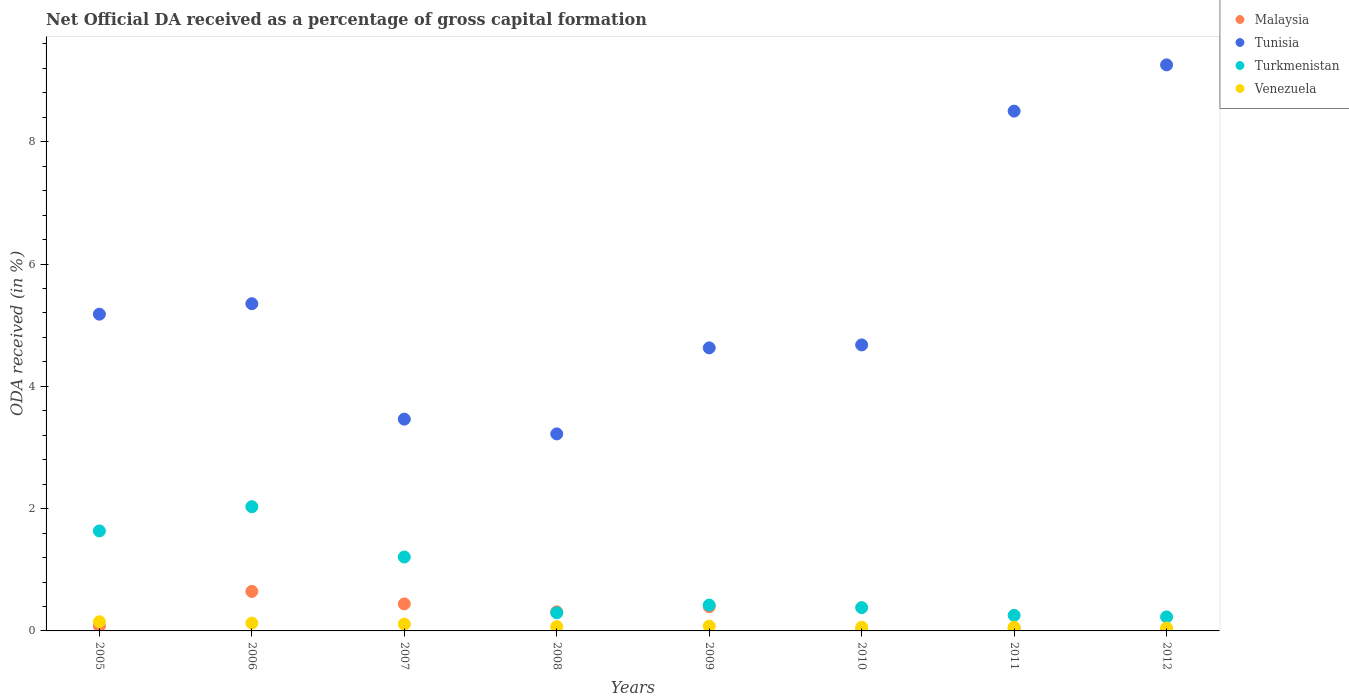How many different coloured dotlines are there?
Offer a terse response. 4. What is the net ODA received in Malaysia in 2009?
Offer a terse response. 0.4. Across all years, what is the maximum net ODA received in Venezuela?
Offer a terse response. 0.15. Across all years, what is the minimum net ODA received in Turkmenistan?
Your answer should be compact. 0.23. In which year was the net ODA received in Tunisia maximum?
Provide a succinct answer. 2012. What is the total net ODA received in Tunisia in the graph?
Your answer should be compact. 44.28. What is the difference between the net ODA received in Malaysia in 2007 and that in 2008?
Make the answer very short. 0.13. What is the difference between the net ODA received in Tunisia in 2011 and the net ODA received in Venezuela in 2012?
Offer a very short reply. 8.45. What is the average net ODA received in Venezuela per year?
Keep it short and to the point. 0.09. In the year 2010, what is the difference between the net ODA received in Venezuela and net ODA received in Malaysia?
Your answer should be very brief. 0.06. In how many years, is the net ODA received in Tunisia greater than 2 %?
Your response must be concise. 8. What is the ratio of the net ODA received in Turkmenistan in 2007 to that in 2011?
Your response must be concise. 4.75. Is the difference between the net ODA received in Venezuela in 2006 and 2012 greater than the difference between the net ODA received in Malaysia in 2006 and 2012?
Provide a succinct answer. No. What is the difference between the highest and the second highest net ODA received in Tunisia?
Provide a succinct answer. 0.76. What is the difference between the highest and the lowest net ODA received in Tunisia?
Provide a succinct answer. 6.03. Is it the case that in every year, the sum of the net ODA received in Venezuela and net ODA received in Turkmenistan  is greater than the sum of net ODA received in Tunisia and net ODA received in Malaysia?
Provide a succinct answer. No. Is it the case that in every year, the sum of the net ODA received in Tunisia and net ODA received in Turkmenistan  is greater than the net ODA received in Malaysia?
Ensure brevity in your answer.  Yes. Is the net ODA received in Tunisia strictly greater than the net ODA received in Malaysia over the years?
Ensure brevity in your answer.  Yes. Is the net ODA received in Tunisia strictly less than the net ODA received in Venezuela over the years?
Give a very brief answer. No. How many years are there in the graph?
Keep it short and to the point. 8. What is the difference between two consecutive major ticks on the Y-axis?
Keep it short and to the point. 2. Does the graph contain any zero values?
Your answer should be very brief. No. Does the graph contain grids?
Keep it short and to the point. No. How many legend labels are there?
Provide a short and direct response. 4. What is the title of the graph?
Offer a terse response. Net Official DA received as a percentage of gross capital formation. What is the label or title of the Y-axis?
Keep it short and to the point. ODA received (in %). What is the ODA received (in %) in Malaysia in 2005?
Make the answer very short. 0.08. What is the ODA received (in %) of Tunisia in 2005?
Provide a succinct answer. 5.18. What is the ODA received (in %) of Turkmenistan in 2005?
Provide a succinct answer. 1.64. What is the ODA received (in %) in Venezuela in 2005?
Make the answer very short. 0.15. What is the ODA received (in %) in Malaysia in 2006?
Offer a very short reply. 0.65. What is the ODA received (in %) in Tunisia in 2006?
Ensure brevity in your answer.  5.35. What is the ODA received (in %) in Turkmenistan in 2006?
Your answer should be very brief. 2.03. What is the ODA received (in %) in Venezuela in 2006?
Ensure brevity in your answer.  0.13. What is the ODA received (in %) in Malaysia in 2007?
Provide a succinct answer. 0.44. What is the ODA received (in %) of Tunisia in 2007?
Keep it short and to the point. 3.46. What is the ODA received (in %) of Turkmenistan in 2007?
Provide a short and direct response. 1.21. What is the ODA received (in %) of Venezuela in 2007?
Provide a short and direct response. 0.11. What is the ODA received (in %) of Malaysia in 2008?
Give a very brief answer. 0.31. What is the ODA received (in %) of Tunisia in 2008?
Provide a succinct answer. 3.22. What is the ODA received (in %) in Turkmenistan in 2008?
Make the answer very short. 0.3. What is the ODA received (in %) of Venezuela in 2008?
Keep it short and to the point. 0.07. What is the ODA received (in %) of Malaysia in 2009?
Keep it short and to the point. 0.4. What is the ODA received (in %) in Tunisia in 2009?
Your response must be concise. 4.63. What is the ODA received (in %) of Turkmenistan in 2009?
Your answer should be very brief. 0.42. What is the ODA received (in %) in Venezuela in 2009?
Keep it short and to the point. 0.08. What is the ODA received (in %) in Malaysia in 2010?
Provide a short and direct response. 0. What is the ODA received (in %) in Tunisia in 2010?
Provide a succinct answer. 4.68. What is the ODA received (in %) in Turkmenistan in 2010?
Offer a terse response. 0.38. What is the ODA received (in %) in Venezuela in 2010?
Your response must be concise. 0.06. What is the ODA received (in %) of Malaysia in 2011?
Provide a short and direct response. 0.05. What is the ODA received (in %) of Tunisia in 2011?
Your response must be concise. 8.5. What is the ODA received (in %) of Turkmenistan in 2011?
Your answer should be compact. 0.25. What is the ODA received (in %) in Venezuela in 2011?
Your answer should be compact. 0.06. What is the ODA received (in %) in Malaysia in 2012?
Offer a very short reply. 0.02. What is the ODA received (in %) in Tunisia in 2012?
Make the answer very short. 9.26. What is the ODA received (in %) in Turkmenistan in 2012?
Ensure brevity in your answer.  0.23. What is the ODA received (in %) in Venezuela in 2012?
Your response must be concise. 0.05. Across all years, what is the maximum ODA received (in %) in Malaysia?
Keep it short and to the point. 0.65. Across all years, what is the maximum ODA received (in %) of Tunisia?
Your answer should be compact. 9.26. Across all years, what is the maximum ODA received (in %) of Turkmenistan?
Your answer should be very brief. 2.03. Across all years, what is the maximum ODA received (in %) of Venezuela?
Offer a terse response. 0.15. Across all years, what is the minimum ODA received (in %) of Malaysia?
Provide a succinct answer. 0. Across all years, what is the minimum ODA received (in %) in Tunisia?
Provide a succinct answer. 3.22. Across all years, what is the minimum ODA received (in %) in Turkmenistan?
Offer a terse response. 0.23. Across all years, what is the minimum ODA received (in %) in Venezuela?
Make the answer very short. 0.05. What is the total ODA received (in %) of Malaysia in the graph?
Your answer should be compact. 1.95. What is the total ODA received (in %) in Tunisia in the graph?
Your answer should be very brief. 44.28. What is the total ODA received (in %) in Turkmenistan in the graph?
Offer a very short reply. 6.46. What is the total ODA received (in %) in Venezuela in the graph?
Keep it short and to the point. 0.71. What is the difference between the ODA received (in %) of Malaysia in 2005 and that in 2006?
Provide a succinct answer. -0.56. What is the difference between the ODA received (in %) of Tunisia in 2005 and that in 2006?
Ensure brevity in your answer.  -0.17. What is the difference between the ODA received (in %) in Turkmenistan in 2005 and that in 2006?
Offer a terse response. -0.4. What is the difference between the ODA received (in %) in Venezuela in 2005 and that in 2006?
Provide a succinct answer. 0.02. What is the difference between the ODA received (in %) of Malaysia in 2005 and that in 2007?
Make the answer very short. -0.36. What is the difference between the ODA received (in %) of Tunisia in 2005 and that in 2007?
Make the answer very short. 1.72. What is the difference between the ODA received (in %) of Turkmenistan in 2005 and that in 2007?
Your response must be concise. 0.43. What is the difference between the ODA received (in %) of Venezuela in 2005 and that in 2007?
Make the answer very short. 0.04. What is the difference between the ODA received (in %) of Malaysia in 2005 and that in 2008?
Keep it short and to the point. -0.23. What is the difference between the ODA received (in %) of Tunisia in 2005 and that in 2008?
Provide a short and direct response. 1.96. What is the difference between the ODA received (in %) in Turkmenistan in 2005 and that in 2008?
Make the answer very short. 1.34. What is the difference between the ODA received (in %) of Venezuela in 2005 and that in 2008?
Your answer should be compact. 0.08. What is the difference between the ODA received (in %) of Malaysia in 2005 and that in 2009?
Offer a very short reply. -0.31. What is the difference between the ODA received (in %) of Tunisia in 2005 and that in 2009?
Give a very brief answer. 0.55. What is the difference between the ODA received (in %) in Turkmenistan in 2005 and that in 2009?
Your answer should be very brief. 1.21. What is the difference between the ODA received (in %) of Venezuela in 2005 and that in 2009?
Provide a short and direct response. 0.07. What is the difference between the ODA received (in %) of Malaysia in 2005 and that in 2010?
Give a very brief answer. 0.08. What is the difference between the ODA received (in %) in Tunisia in 2005 and that in 2010?
Ensure brevity in your answer.  0.5. What is the difference between the ODA received (in %) in Turkmenistan in 2005 and that in 2010?
Your response must be concise. 1.25. What is the difference between the ODA received (in %) in Venezuela in 2005 and that in 2010?
Provide a succinct answer. 0.09. What is the difference between the ODA received (in %) in Malaysia in 2005 and that in 2011?
Ensure brevity in your answer.  0.03. What is the difference between the ODA received (in %) of Tunisia in 2005 and that in 2011?
Make the answer very short. -3.32. What is the difference between the ODA received (in %) in Turkmenistan in 2005 and that in 2011?
Provide a short and direct response. 1.38. What is the difference between the ODA received (in %) in Venezuela in 2005 and that in 2011?
Your response must be concise. 0.09. What is the difference between the ODA received (in %) of Malaysia in 2005 and that in 2012?
Give a very brief answer. 0.06. What is the difference between the ODA received (in %) of Tunisia in 2005 and that in 2012?
Your answer should be compact. -4.08. What is the difference between the ODA received (in %) in Turkmenistan in 2005 and that in 2012?
Your response must be concise. 1.41. What is the difference between the ODA received (in %) of Venezuela in 2005 and that in 2012?
Your answer should be very brief. 0.1. What is the difference between the ODA received (in %) of Malaysia in 2006 and that in 2007?
Provide a short and direct response. 0.2. What is the difference between the ODA received (in %) in Tunisia in 2006 and that in 2007?
Give a very brief answer. 1.89. What is the difference between the ODA received (in %) of Turkmenistan in 2006 and that in 2007?
Your answer should be very brief. 0.82. What is the difference between the ODA received (in %) of Venezuela in 2006 and that in 2007?
Your response must be concise. 0.02. What is the difference between the ODA received (in %) in Malaysia in 2006 and that in 2008?
Your answer should be compact. 0.33. What is the difference between the ODA received (in %) in Tunisia in 2006 and that in 2008?
Provide a succinct answer. 2.13. What is the difference between the ODA received (in %) in Turkmenistan in 2006 and that in 2008?
Make the answer very short. 1.73. What is the difference between the ODA received (in %) of Venezuela in 2006 and that in 2008?
Provide a short and direct response. 0.06. What is the difference between the ODA received (in %) in Tunisia in 2006 and that in 2009?
Offer a very short reply. 0.72. What is the difference between the ODA received (in %) in Turkmenistan in 2006 and that in 2009?
Provide a succinct answer. 1.61. What is the difference between the ODA received (in %) in Venezuela in 2006 and that in 2009?
Give a very brief answer. 0.05. What is the difference between the ODA received (in %) in Malaysia in 2006 and that in 2010?
Give a very brief answer. 0.64. What is the difference between the ODA received (in %) of Tunisia in 2006 and that in 2010?
Keep it short and to the point. 0.67. What is the difference between the ODA received (in %) in Turkmenistan in 2006 and that in 2010?
Your response must be concise. 1.65. What is the difference between the ODA received (in %) in Venezuela in 2006 and that in 2010?
Ensure brevity in your answer.  0.07. What is the difference between the ODA received (in %) of Malaysia in 2006 and that in 2011?
Offer a very short reply. 0.6. What is the difference between the ODA received (in %) in Tunisia in 2006 and that in 2011?
Make the answer very short. -3.15. What is the difference between the ODA received (in %) in Turkmenistan in 2006 and that in 2011?
Provide a short and direct response. 1.78. What is the difference between the ODA received (in %) of Venezuela in 2006 and that in 2011?
Give a very brief answer. 0.07. What is the difference between the ODA received (in %) in Malaysia in 2006 and that in 2012?
Your response must be concise. 0.63. What is the difference between the ODA received (in %) in Tunisia in 2006 and that in 2012?
Ensure brevity in your answer.  -3.91. What is the difference between the ODA received (in %) of Turkmenistan in 2006 and that in 2012?
Offer a very short reply. 1.8. What is the difference between the ODA received (in %) in Venezuela in 2006 and that in 2012?
Ensure brevity in your answer.  0.08. What is the difference between the ODA received (in %) in Malaysia in 2007 and that in 2008?
Your answer should be compact. 0.13. What is the difference between the ODA received (in %) in Tunisia in 2007 and that in 2008?
Your answer should be very brief. 0.24. What is the difference between the ODA received (in %) in Turkmenistan in 2007 and that in 2008?
Your answer should be very brief. 0.91. What is the difference between the ODA received (in %) in Venezuela in 2007 and that in 2008?
Provide a succinct answer. 0.04. What is the difference between the ODA received (in %) of Malaysia in 2007 and that in 2009?
Your answer should be very brief. 0.05. What is the difference between the ODA received (in %) of Tunisia in 2007 and that in 2009?
Give a very brief answer. -1.17. What is the difference between the ODA received (in %) of Turkmenistan in 2007 and that in 2009?
Offer a terse response. 0.79. What is the difference between the ODA received (in %) of Venezuela in 2007 and that in 2009?
Offer a terse response. 0.03. What is the difference between the ODA received (in %) of Malaysia in 2007 and that in 2010?
Ensure brevity in your answer.  0.44. What is the difference between the ODA received (in %) in Tunisia in 2007 and that in 2010?
Ensure brevity in your answer.  -1.21. What is the difference between the ODA received (in %) of Turkmenistan in 2007 and that in 2010?
Keep it short and to the point. 0.83. What is the difference between the ODA received (in %) of Venezuela in 2007 and that in 2010?
Your answer should be compact. 0.05. What is the difference between the ODA received (in %) in Malaysia in 2007 and that in 2011?
Provide a succinct answer. 0.4. What is the difference between the ODA received (in %) of Tunisia in 2007 and that in 2011?
Give a very brief answer. -5.04. What is the difference between the ODA received (in %) in Turkmenistan in 2007 and that in 2011?
Your response must be concise. 0.95. What is the difference between the ODA received (in %) in Venezuela in 2007 and that in 2011?
Offer a very short reply. 0.05. What is the difference between the ODA received (in %) of Malaysia in 2007 and that in 2012?
Provide a short and direct response. 0.42. What is the difference between the ODA received (in %) of Tunisia in 2007 and that in 2012?
Provide a short and direct response. -5.79. What is the difference between the ODA received (in %) of Turkmenistan in 2007 and that in 2012?
Your response must be concise. 0.98. What is the difference between the ODA received (in %) of Venezuela in 2007 and that in 2012?
Give a very brief answer. 0.06. What is the difference between the ODA received (in %) of Malaysia in 2008 and that in 2009?
Provide a succinct answer. -0.08. What is the difference between the ODA received (in %) of Tunisia in 2008 and that in 2009?
Give a very brief answer. -1.41. What is the difference between the ODA received (in %) in Turkmenistan in 2008 and that in 2009?
Make the answer very short. -0.13. What is the difference between the ODA received (in %) in Venezuela in 2008 and that in 2009?
Your answer should be compact. -0.01. What is the difference between the ODA received (in %) in Malaysia in 2008 and that in 2010?
Keep it short and to the point. 0.31. What is the difference between the ODA received (in %) of Tunisia in 2008 and that in 2010?
Make the answer very short. -1.45. What is the difference between the ODA received (in %) of Turkmenistan in 2008 and that in 2010?
Provide a short and direct response. -0.08. What is the difference between the ODA received (in %) of Venezuela in 2008 and that in 2010?
Ensure brevity in your answer.  0.01. What is the difference between the ODA received (in %) of Malaysia in 2008 and that in 2011?
Offer a terse response. 0.27. What is the difference between the ODA received (in %) in Tunisia in 2008 and that in 2011?
Ensure brevity in your answer.  -5.28. What is the difference between the ODA received (in %) of Turkmenistan in 2008 and that in 2011?
Offer a terse response. 0.04. What is the difference between the ODA received (in %) in Venezuela in 2008 and that in 2011?
Make the answer very short. 0.01. What is the difference between the ODA received (in %) in Malaysia in 2008 and that in 2012?
Your answer should be very brief. 0.29. What is the difference between the ODA received (in %) of Tunisia in 2008 and that in 2012?
Provide a short and direct response. -6.03. What is the difference between the ODA received (in %) of Turkmenistan in 2008 and that in 2012?
Offer a very short reply. 0.07. What is the difference between the ODA received (in %) in Venezuela in 2008 and that in 2012?
Your answer should be very brief. 0.02. What is the difference between the ODA received (in %) of Malaysia in 2009 and that in 2010?
Ensure brevity in your answer.  0.39. What is the difference between the ODA received (in %) in Tunisia in 2009 and that in 2010?
Your response must be concise. -0.05. What is the difference between the ODA received (in %) in Turkmenistan in 2009 and that in 2010?
Your answer should be compact. 0.04. What is the difference between the ODA received (in %) of Venezuela in 2009 and that in 2010?
Provide a succinct answer. 0.02. What is the difference between the ODA received (in %) of Malaysia in 2009 and that in 2011?
Provide a short and direct response. 0.35. What is the difference between the ODA received (in %) of Tunisia in 2009 and that in 2011?
Offer a very short reply. -3.87. What is the difference between the ODA received (in %) of Turkmenistan in 2009 and that in 2011?
Give a very brief answer. 0.17. What is the difference between the ODA received (in %) of Venezuela in 2009 and that in 2011?
Keep it short and to the point. 0.02. What is the difference between the ODA received (in %) in Malaysia in 2009 and that in 2012?
Offer a terse response. 0.38. What is the difference between the ODA received (in %) in Tunisia in 2009 and that in 2012?
Provide a short and direct response. -4.63. What is the difference between the ODA received (in %) in Turkmenistan in 2009 and that in 2012?
Your answer should be compact. 0.19. What is the difference between the ODA received (in %) in Venezuela in 2009 and that in 2012?
Provide a short and direct response. 0.03. What is the difference between the ODA received (in %) in Malaysia in 2010 and that in 2011?
Keep it short and to the point. -0.04. What is the difference between the ODA received (in %) in Tunisia in 2010 and that in 2011?
Offer a very short reply. -3.82. What is the difference between the ODA received (in %) in Turkmenistan in 2010 and that in 2011?
Provide a short and direct response. 0.13. What is the difference between the ODA received (in %) in Venezuela in 2010 and that in 2011?
Provide a short and direct response. -0. What is the difference between the ODA received (in %) of Malaysia in 2010 and that in 2012?
Ensure brevity in your answer.  -0.02. What is the difference between the ODA received (in %) in Tunisia in 2010 and that in 2012?
Your response must be concise. -4.58. What is the difference between the ODA received (in %) in Turkmenistan in 2010 and that in 2012?
Offer a very short reply. 0.15. What is the difference between the ODA received (in %) of Venezuela in 2010 and that in 2012?
Your answer should be very brief. 0.01. What is the difference between the ODA received (in %) in Malaysia in 2011 and that in 2012?
Make the answer very short. 0.03. What is the difference between the ODA received (in %) in Tunisia in 2011 and that in 2012?
Your answer should be very brief. -0.76. What is the difference between the ODA received (in %) of Turkmenistan in 2011 and that in 2012?
Ensure brevity in your answer.  0.03. What is the difference between the ODA received (in %) of Venezuela in 2011 and that in 2012?
Your response must be concise. 0.01. What is the difference between the ODA received (in %) of Malaysia in 2005 and the ODA received (in %) of Tunisia in 2006?
Provide a short and direct response. -5.27. What is the difference between the ODA received (in %) in Malaysia in 2005 and the ODA received (in %) in Turkmenistan in 2006?
Your answer should be compact. -1.95. What is the difference between the ODA received (in %) in Malaysia in 2005 and the ODA received (in %) in Venezuela in 2006?
Provide a succinct answer. -0.05. What is the difference between the ODA received (in %) of Tunisia in 2005 and the ODA received (in %) of Turkmenistan in 2006?
Your answer should be compact. 3.15. What is the difference between the ODA received (in %) of Tunisia in 2005 and the ODA received (in %) of Venezuela in 2006?
Keep it short and to the point. 5.05. What is the difference between the ODA received (in %) of Turkmenistan in 2005 and the ODA received (in %) of Venezuela in 2006?
Give a very brief answer. 1.51. What is the difference between the ODA received (in %) in Malaysia in 2005 and the ODA received (in %) in Tunisia in 2007?
Give a very brief answer. -3.38. What is the difference between the ODA received (in %) of Malaysia in 2005 and the ODA received (in %) of Turkmenistan in 2007?
Make the answer very short. -1.13. What is the difference between the ODA received (in %) in Malaysia in 2005 and the ODA received (in %) in Venezuela in 2007?
Ensure brevity in your answer.  -0.03. What is the difference between the ODA received (in %) of Tunisia in 2005 and the ODA received (in %) of Turkmenistan in 2007?
Keep it short and to the point. 3.97. What is the difference between the ODA received (in %) of Tunisia in 2005 and the ODA received (in %) of Venezuela in 2007?
Your response must be concise. 5.07. What is the difference between the ODA received (in %) of Turkmenistan in 2005 and the ODA received (in %) of Venezuela in 2007?
Your answer should be very brief. 1.52. What is the difference between the ODA received (in %) of Malaysia in 2005 and the ODA received (in %) of Tunisia in 2008?
Provide a short and direct response. -3.14. What is the difference between the ODA received (in %) of Malaysia in 2005 and the ODA received (in %) of Turkmenistan in 2008?
Make the answer very short. -0.22. What is the difference between the ODA received (in %) of Malaysia in 2005 and the ODA received (in %) of Venezuela in 2008?
Your answer should be compact. 0.01. What is the difference between the ODA received (in %) in Tunisia in 2005 and the ODA received (in %) in Turkmenistan in 2008?
Make the answer very short. 4.88. What is the difference between the ODA received (in %) in Tunisia in 2005 and the ODA received (in %) in Venezuela in 2008?
Keep it short and to the point. 5.11. What is the difference between the ODA received (in %) in Turkmenistan in 2005 and the ODA received (in %) in Venezuela in 2008?
Offer a terse response. 1.57. What is the difference between the ODA received (in %) of Malaysia in 2005 and the ODA received (in %) of Tunisia in 2009?
Provide a short and direct response. -4.55. What is the difference between the ODA received (in %) in Malaysia in 2005 and the ODA received (in %) in Turkmenistan in 2009?
Keep it short and to the point. -0.34. What is the difference between the ODA received (in %) in Malaysia in 2005 and the ODA received (in %) in Venezuela in 2009?
Make the answer very short. 0. What is the difference between the ODA received (in %) of Tunisia in 2005 and the ODA received (in %) of Turkmenistan in 2009?
Make the answer very short. 4.76. What is the difference between the ODA received (in %) of Tunisia in 2005 and the ODA received (in %) of Venezuela in 2009?
Keep it short and to the point. 5.1. What is the difference between the ODA received (in %) of Turkmenistan in 2005 and the ODA received (in %) of Venezuela in 2009?
Your response must be concise. 1.56. What is the difference between the ODA received (in %) of Malaysia in 2005 and the ODA received (in %) of Tunisia in 2010?
Your response must be concise. -4.6. What is the difference between the ODA received (in %) of Malaysia in 2005 and the ODA received (in %) of Turkmenistan in 2010?
Your response must be concise. -0.3. What is the difference between the ODA received (in %) in Malaysia in 2005 and the ODA received (in %) in Venezuela in 2010?
Offer a terse response. 0.02. What is the difference between the ODA received (in %) of Tunisia in 2005 and the ODA received (in %) of Turkmenistan in 2010?
Your response must be concise. 4.8. What is the difference between the ODA received (in %) in Tunisia in 2005 and the ODA received (in %) in Venezuela in 2010?
Your answer should be very brief. 5.12. What is the difference between the ODA received (in %) in Turkmenistan in 2005 and the ODA received (in %) in Venezuela in 2010?
Offer a terse response. 1.57. What is the difference between the ODA received (in %) of Malaysia in 2005 and the ODA received (in %) of Tunisia in 2011?
Make the answer very short. -8.42. What is the difference between the ODA received (in %) in Malaysia in 2005 and the ODA received (in %) in Turkmenistan in 2011?
Your answer should be compact. -0.17. What is the difference between the ODA received (in %) in Malaysia in 2005 and the ODA received (in %) in Venezuela in 2011?
Keep it short and to the point. 0.02. What is the difference between the ODA received (in %) of Tunisia in 2005 and the ODA received (in %) of Turkmenistan in 2011?
Provide a succinct answer. 4.93. What is the difference between the ODA received (in %) of Tunisia in 2005 and the ODA received (in %) of Venezuela in 2011?
Keep it short and to the point. 5.12. What is the difference between the ODA received (in %) of Turkmenistan in 2005 and the ODA received (in %) of Venezuela in 2011?
Provide a succinct answer. 1.57. What is the difference between the ODA received (in %) in Malaysia in 2005 and the ODA received (in %) in Tunisia in 2012?
Provide a short and direct response. -9.18. What is the difference between the ODA received (in %) of Malaysia in 2005 and the ODA received (in %) of Turkmenistan in 2012?
Keep it short and to the point. -0.15. What is the difference between the ODA received (in %) of Malaysia in 2005 and the ODA received (in %) of Venezuela in 2012?
Offer a very short reply. 0.03. What is the difference between the ODA received (in %) in Tunisia in 2005 and the ODA received (in %) in Turkmenistan in 2012?
Your response must be concise. 4.95. What is the difference between the ODA received (in %) in Tunisia in 2005 and the ODA received (in %) in Venezuela in 2012?
Your response must be concise. 5.13. What is the difference between the ODA received (in %) of Turkmenistan in 2005 and the ODA received (in %) of Venezuela in 2012?
Your answer should be very brief. 1.59. What is the difference between the ODA received (in %) of Malaysia in 2006 and the ODA received (in %) of Tunisia in 2007?
Offer a very short reply. -2.82. What is the difference between the ODA received (in %) in Malaysia in 2006 and the ODA received (in %) in Turkmenistan in 2007?
Provide a short and direct response. -0.56. What is the difference between the ODA received (in %) of Malaysia in 2006 and the ODA received (in %) of Venezuela in 2007?
Offer a terse response. 0.54. What is the difference between the ODA received (in %) in Tunisia in 2006 and the ODA received (in %) in Turkmenistan in 2007?
Offer a terse response. 4.14. What is the difference between the ODA received (in %) of Tunisia in 2006 and the ODA received (in %) of Venezuela in 2007?
Offer a terse response. 5.24. What is the difference between the ODA received (in %) of Turkmenistan in 2006 and the ODA received (in %) of Venezuela in 2007?
Ensure brevity in your answer.  1.92. What is the difference between the ODA received (in %) of Malaysia in 2006 and the ODA received (in %) of Tunisia in 2008?
Your answer should be very brief. -2.58. What is the difference between the ODA received (in %) in Malaysia in 2006 and the ODA received (in %) in Turkmenistan in 2008?
Your answer should be very brief. 0.35. What is the difference between the ODA received (in %) of Malaysia in 2006 and the ODA received (in %) of Venezuela in 2008?
Give a very brief answer. 0.58. What is the difference between the ODA received (in %) in Tunisia in 2006 and the ODA received (in %) in Turkmenistan in 2008?
Your answer should be compact. 5.05. What is the difference between the ODA received (in %) in Tunisia in 2006 and the ODA received (in %) in Venezuela in 2008?
Give a very brief answer. 5.28. What is the difference between the ODA received (in %) of Turkmenistan in 2006 and the ODA received (in %) of Venezuela in 2008?
Give a very brief answer. 1.96. What is the difference between the ODA received (in %) in Malaysia in 2006 and the ODA received (in %) in Tunisia in 2009?
Your answer should be very brief. -3.98. What is the difference between the ODA received (in %) in Malaysia in 2006 and the ODA received (in %) in Turkmenistan in 2009?
Your answer should be very brief. 0.22. What is the difference between the ODA received (in %) of Malaysia in 2006 and the ODA received (in %) of Venezuela in 2009?
Offer a terse response. 0.57. What is the difference between the ODA received (in %) of Tunisia in 2006 and the ODA received (in %) of Turkmenistan in 2009?
Your answer should be compact. 4.93. What is the difference between the ODA received (in %) in Tunisia in 2006 and the ODA received (in %) in Venezuela in 2009?
Your answer should be very brief. 5.27. What is the difference between the ODA received (in %) in Turkmenistan in 2006 and the ODA received (in %) in Venezuela in 2009?
Provide a succinct answer. 1.95. What is the difference between the ODA received (in %) of Malaysia in 2006 and the ODA received (in %) of Tunisia in 2010?
Provide a short and direct response. -4.03. What is the difference between the ODA received (in %) in Malaysia in 2006 and the ODA received (in %) in Turkmenistan in 2010?
Keep it short and to the point. 0.27. What is the difference between the ODA received (in %) in Malaysia in 2006 and the ODA received (in %) in Venezuela in 2010?
Provide a succinct answer. 0.59. What is the difference between the ODA received (in %) of Tunisia in 2006 and the ODA received (in %) of Turkmenistan in 2010?
Make the answer very short. 4.97. What is the difference between the ODA received (in %) in Tunisia in 2006 and the ODA received (in %) in Venezuela in 2010?
Provide a succinct answer. 5.29. What is the difference between the ODA received (in %) of Turkmenistan in 2006 and the ODA received (in %) of Venezuela in 2010?
Your answer should be very brief. 1.97. What is the difference between the ODA received (in %) of Malaysia in 2006 and the ODA received (in %) of Tunisia in 2011?
Your response must be concise. -7.85. What is the difference between the ODA received (in %) in Malaysia in 2006 and the ODA received (in %) in Turkmenistan in 2011?
Offer a very short reply. 0.39. What is the difference between the ODA received (in %) of Malaysia in 2006 and the ODA received (in %) of Venezuela in 2011?
Give a very brief answer. 0.58. What is the difference between the ODA received (in %) in Tunisia in 2006 and the ODA received (in %) in Turkmenistan in 2011?
Your answer should be very brief. 5.1. What is the difference between the ODA received (in %) in Tunisia in 2006 and the ODA received (in %) in Venezuela in 2011?
Your answer should be very brief. 5.29. What is the difference between the ODA received (in %) in Turkmenistan in 2006 and the ODA received (in %) in Venezuela in 2011?
Offer a very short reply. 1.97. What is the difference between the ODA received (in %) of Malaysia in 2006 and the ODA received (in %) of Tunisia in 2012?
Give a very brief answer. -8.61. What is the difference between the ODA received (in %) of Malaysia in 2006 and the ODA received (in %) of Turkmenistan in 2012?
Your response must be concise. 0.42. What is the difference between the ODA received (in %) in Malaysia in 2006 and the ODA received (in %) in Venezuela in 2012?
Offer a very short reply. 0.6. What is the difference between the ODA received (in %) of Tunisia in 2006 and the ODA received (in %) of Turkmenistan in 2012?
Provide a short and direct response. 5.12. What is the difference between the ODA received (in %) of Tunisia in 2006 and the ODA received (in %) of Venezuela in 2012?
Provide a short and direct response. 5.3. What is the difference between the ODA received (in %) of Turkmenistan in 2006 and the ODA received (in %) of Venezuela in 2012?
Provide a short and direct response. 1.98. What is the difference between the ODA received (in %) of Malaysia in 2007 and the ODA received (in %) of Tunisia in 2008?
Your response must be concise. -2.78. What is the difference between the ODA received (in %) of Malaysia in 2007 and the ODA received (in %) of Turkmenistan in 2008?
Provide a short and direct response. 0.14. What is the difference between the ODA received (in %) of Malaysia in 2007 and the ODA received (in %) of Venezuela in 2008?
Offer a terse response. 0.37. What is the difference between the ODA received (in %) in Tunisia in 2007 and the ODA received (in %) in Turkmenistan in 2008?
Provide a short and direct response. 3.17. What is the difference between the ODA received (in %) of Tunisia in 2007 and the ODA received (in %) of Venezuela in 2008?
Give a very brief answer. 3.39. What is the difference between the ODA received (in %) in Turkmenistan in 2007 and the ODA received (in %) in Venezuela in 2008?
Provide a succinct answer. 1.14. What is the difference between the ODA received (in %) in Malaysia in 2007 and the ODA received (in %) in Tunisia in 2009?
Ensure brevity in your answer.  -4.19. What is the difference between the ODA received (in %) in Malaysia in 2007 and the ODA received (in %) in Turkmenistan in 2009?
Your response must be concise. 0.02. What is the difference between the ODA received (in %) in Malaysia in 2007 and the ODA received (in %) in Venezuela in 2009?
Your response must be concise. 0.36. What is the difference between the ODA received (in %) of Tunisia in 2007 and the ODA received (in %) of Turkmenistan in 2009?
Ensure brevity in your answer.  3.04. What is the difference between the ODA received (in %) in Tunisia in 2007 and the ODA received (in %) in Venezuela in 2009?
Offer a very short reply. 3.39. What is the difference between the ODA received (in %) of Turkmenistan in 2007 and the ODA received (in %) of Venezuela in 2009?
Offer a very short reply. 1.13. What is the difference between the ODA received (in %) in Malaysia in 2007 and the ODA received (in %) in Tunisia in 2010?
Give a very brief answer. -4.24. What is the difference between the ODA received (in %) in Malaysia in 2007 and the ODA received (in %) in Turkmenistan in 2010?
Your answer should be compact. 0.06. What is the difference between the ODA received (in %) of Malaysia in 2007 and the ODA received (in %) of Venezuela in 2010?
Provide a short and direct response. 0.38. What is the difference between the ODA received (in %) in Tunisia in 2007 and the ODA received (in %) in Turkmenistan in 2010?
Your response must be concise. 3.08. What is the difference between the ODA received (in %) of Tunisia in 2007 and the ODA received (in %) of Venezuela in 2010?
Your answer should be compact. 3.4. What is the difference between the ODA received (in %) in Turkmenistan in 2007 and the ODA received (in %) in Venezuela in 2010?
Offer a terse response. 1.15. What is the difference between the ODA received (in %) in Malaysia in 2007 and the ODA received (in %) in Tunisia in 2011?
Your response must be concise. -8.06. What is the difference between the ODA received (in %) in Malaysia in 2007 and the ODA received (in %) in Turkmenistan in 2011?
Your answer should be very brief. 0.19. What is the difference between the ODA received (in %) of Malaysia in 2007 and the ODA received (in %) of Venezuela in 2011?
Your answer should be compact. 0.38. What is the difference between the ODA received (in %) of Tunisia in 2007 and the ODA received (in %) of Turkmenistan in 2011?
Offer a very short reply. 3.21. What is the difference between the ODA received (in %) of Tunisia in 2007 and the ODA received (in %) of Venezuela in 2011?
Your response must be concise. 3.4. What is the difference between the ODA received (in %) in Turkmenistan in 2007 and the ODA received (in %) in Venezuela in 2011?
Ensure brevity in your answer.  1.15. What is the difference between the ODA received (in %) of Malaysia in 2007 and the ODA received (in %) of Tunisia in 2012?
Provide a succinct answer. -8.82. What is the difference between the ODA received (in %) in Malaysia in 2007 and the ODA received (in %) in Turkmenistan in 2012?
Your answer should be compact. 0.21. What is the difference between the ODA received (in %) in Malaysia in 2007 and the ODA received (in %) in Venezuela in 2012?
Offer a very short reply. 0.39. What is the difference between the ODA received (in %) of Tunisia in 2007 and the ODA received (in %) of Turkmenistan in 2012?
Provide a short and direct response. 3.23. What is the difference between the ODA received (in %) in Tunisia in 2007 and the ODA received (in %) in Venezuela in 2012?
Provide a succinct answer. 3.42. What is the difference between the ODA received (in %) in Turkmenistan in 2007 and the ODA received (in %) in Venezuela in 2012?
Give a very brief answer. 1.16. What is the difference between the ODA received (in %) in Malaysia in 2008 and the ODA received (in %) in Tunisia in 2009?
Your answer should be very brief. -4.32. What is the difference between the ODA received (in %) of Malaysia in 2008 and the ODA received (in %) of Turkmenistan in 2009?
Keep it short and to the point. -0.11. What is the difference between the ODA received (in %) in Malaysia in 2008 and the ODA received (in %) in Venezuela in 2009?
Provide a succinct answer. 0.23. What is the difference between the ODA received (in %) of Tunisia in 2008 and the ODA received (in %) of Turkmenistan in 2009?
Keep it short and to the point. 2.8. What is the difference between the ODA received (in %) in Tunisia in 2008 and the ODA received (in %) in Venezuela in 2009?
Your answer should be compact. 3.14. What is the difference between the ODA received (in %) of Turkmenistan in 2008 and the ODA received (in %) of Venezuela in 2009?
Offer a very short reply. 0.22. What is the difference between the ODA received (in %) of Malaysia in 2008 and the ODA received (in %) of Tunisia in 2010?
Offer a terse response. -4.37. What is the difference between the ODA received (in %) of Malaysia in 2008 and the ODA received (in %) of Turkmenistan in 2010?
Your answer should be very brief. -0.07. What is the difference between the ODA received (in %) in Malaysia in 2008 and the ODA received (in %) in Venezuela in 2010?
Ensure brevity in your answer.  0.25. What is the difference between the ODA received (in %) of Tunisia in 2008 and the ODA received (in %) of Turkmenistan in 2010?
Offer a very short reply. 2.84. What is the difference between the ODA received (in %) in Tunisia in 2008 and the ODA received (in %) in Venezuela in 2010?
Your answer should be compact. 3.16. What is the difference between the ODA received (in %) in Turkmenistan in 2008 and the ODA received (in %) in Venezuela in 2010?
Offer a very short reply. 0.24. What is the difference between the ODA received (in %) of Malaysia in 2008 and the ODA received (in %) of Tunisia in 2011?
Your response must be concise. -8.19. What is the difference between the ODA received (in %) in Malaysia in 2008 and the ODA received (in %) in Turkmenistan in 2011?
Your answer should be compact. 0.06. What is the difference between the ODA received (in %) of Malaysia in 2008 and the ODA received (in %) of Venezuela in 2011?
Your answer should be very brief. 0.25. What is the difference between the ODA received (in %) in Tunisia in 2008 and the ODA received (in %) in Turkmenistan in 2011?
Provide a short and direct response. 2.97. What is the difference between the ODA received (in %) in Tunisia in 2008 and the ODA received (in %) in Venezuela in 2011?
Ensure brevity in your answer.  3.16. What is the difference between the ODA received (in %) of Turkmenistan in 2008 and the ODA received (in %) of Venezuela in 2011?
Keep it short and to the point. 0.24. What is the difference between the ODA received (in %) in Malaysia in 2008 and the ODA received (in %) in Tunisia in 2012?
Offer a very short reply. -8.95. What is the difference between the ODA received (in %) of Malaysia in 2008 and the ODA received (in %) of Turkmenistan in 2012?
Your answer should be compact. 0.08. What is the difference between the ODA received (in %) in Malaysia in 2008 and the ODA received (in %) in Venezuela in 2012?
Ensure brevity in your answer.  0.26. What is the difference between the ODA received (in %) in Tunisia in 2008 and the ODA received (in %) in Turkmenistan in 2012?
Your answer should be compact. 2.99. What is the difference between the ODA received (in %) in Tunisia in 2008 and the ODA received (in %) in Venezuela in 2012?
Offer a very short reply. 3.17. What is the difference between the ODA received (in %) in Turkmenistan in 2008 and the ODA received (in %) in Venezuela in 2012?
Give a very brief answer. 0.25. What is the difference between the ODA received (in %) of Malaysia in 2009 and the ODA received (in %) of Tunisia in 2010?
Make the answer very short. -4.28. What is the difference between the ODA received (in %) of Malaysia in 2009 and the ODA received (in %) of Turkmenistan in 2010?
Provide a succinct answer. 0.02. What is the difference between the ODA received (in %) in Malaysia in 2009 and the ODA received (in %) in Venezuela in 2010?
Make the answer very short. 0.34. What is the difference between the ODA received (in %) in Tunisia in 2009 and the ODA received (in %) in Turkmenistan in 2010?
Give a very brief answer. 4.25. What is the difference between the ODA received (in %) in Tunisia in 2009 and the ODA received (in %) in Venezuela in 2010?
Keep it short and to the point. 4.57. What is the difference between the ODA received (in %) of Turkmenistan in 2009 and the ODA received (in %) of Venezuela in 2010?
Your answer should be compact. 0.36. What is the difference between the ODA received (in %) of Malaysia in 2009 and the ODA received (in %) of Tunisia in 2011?
Your answer should be very brief. -8.1. What is the difference between the ODA received (in %) of Malaysia in 2009 and the ODA received (in %) of Turkmenistan in 2011?
Offer a terse response. 0.14. What is the difference between the ODA received (in %) of Malaysia in 2009 and the ODA received (in %) of Venezuela in 2011?
Make the answer very short. 0.33. What is the difference between the ODA received (in %) in Tunisia in 2009 and the ODA received (in %) in Turkmenistan in 2011?
Offer a very short reply. 4.37. What is the difference between the ODA received (in %) of Tunisia in 2009 and the ODA received (in %) of Venezuela in 2011?
Your response must be concise. 4.57. What is the difference between the ODA received (in %) of Turkmenistan in 2009 and the ODA received (in %) of Venezuela in 2011?
Provide a short and direct response. 0.36. What is the difference between the ODA received (in %) of Malaysia in 2009 and the ODA received (in %) of Tunisia in 2012?
Your response must be concise. -8.86. What is the difference between the ODA received (in %) in Malaysia in 2009 and the ODA received (in %) in Turkmenistan in 2012?
Your response must be concise. 0.17. What is the difference between the ODA received (in %) of Malaysia in 2009 and the ODA received (in %) of Venezuela in 2012?
Offer a terse response. 0.35. What is the difference between the ODA received (in %) in Tunisia in 2009 and the ODA received (in %) in Turkmenistan in 2012?
Your answer should be very brief. 4.4. What is the difference between the ODA received (in %) in Tunisia in 2009 and the ODA received (in %) in Venezuela in 2012?
Your answer should be very brief. 4.58. What is the difference between the ODA received (in %) in Turkmenistan in 2009 and the ODA received (in %) in Venezuela in 2012?
Your answer should be compact. 0.38. What is the difference between the ODA received (in %) of Malaysia in 2010 and the ODA received (in %) of Tunisia in 2011?
Keep it short and to the point. -8.5. What is the difference between the ODA received (in %) in Malaysia in 2010 and the ODA received (in %) in Turkmenistan in 2011?
Give a very brief answer. -0.25. What is the difference between the ODA received (in %) of Malaysia in 2010 and the ODA received (in %) of Venezuela in 2011?
Make the answer very short. -0.06. What is the difference between the ODA received (in %) in Tunisia in 2010 and the ODA received (in %) in Turkmenistan in 2011?
Provide a succinct answer. 4.42. What is the difference between the ODA received (in %) of Tunisia in 2010 and the ODA received (in %) of Venezuela in 2011?
Offer a terse response. 4.62. What is the difference between the ODA received (in %) in Turkmenistan in 2010 and the ODA received (in %) in Venezuela in 2011?
Provide a short and direct response. 0.32. What is the difference between the ODA received (in %) in Malaysia in 2010 and the ODA received (in %) in Tunisia in 2012?
Ensure brevity in your answer.  -9.25. What is the difference between the ODA received (in %) in Malaysia in 2010 and the ODA received (in %) in Turkmenistan in 2012?
Your answer should be compact. -0.23. What is the difference between the ODA received (in %) in Malaysia in 2010 and the ODA received (in %) in Venezuela in 2012?
Provide a succinct answer. -0.04. What is the difference between the ODA received (in %) of Tunisia in 2010 and the ODA received (in %) of Turkmenistan in 2012?
Give a very brief answer. 4.45. What is the difference between the ODA received (in %) of Tunisia in 2010 and the ODA received (in %) of Venezuela in 2012?
Give a very brief answer. 4.63. What is the difference between the ODA received (in %) in Turkmenistan in 2010 and the ODA received (in %) in Venezuela in 2012?
Give a very brief answer. 0.33. What is the difference between the ODA received (in %) in Malaysia in 2011 and the ODA received (in %) in Tunisia in 2012?
Your answer should be very brief. -9.21. What is the difference between the ODA received (in %) of Malaysia in 2011 and the ODA received (in %) of Turkmenistan in 2012?
Give a very brief answer. -0.18. What is the difference between the ODA received (in %) of Malaysia in 2011 and the ODA received (in %) of Venezuela in 2012?
Provide a succinct answer. -0. What is the difference between the ODA received (in %) in Tunisia in 2011 and the ODA received (in %) in Turkmenistan in 2012?
Keep it short and to the point. 8.27. What is the difference between the ODA received (in %) of Tunisia in 2011 and the ODA received (in %) of Venezuela in 2012?
Your answer should be compact. 8.45. What is the difference between the ODA received (in %) of Turkmenistan in 2011 and the ODA received (in %) of Venezuela in 2012?
Provide a succinct answer. 0.21. What is the average ODA received (in %) in Malaysia per year?
Provide a short and direct response. 0.24. What is the average ODA received (in %) in Tunisia per year?
Provide a short and direct response. 5.54. What is the average ODA received (in %) in Turkmenistan per year?
Give a very brief answer. 0.81. What is the average ODA received (in %) of Venezuela per year?
Your answer should be very brief. 0.09. In the year 2005, what is the difference between the ODA received (in %) of Malaysia and ODA received (in %) of Tunisia?
Make the answer very short. -5.1. In the year 2005, what is the difference between the ODA received (in %) in Malaysia and ODA received (in %) in Turkmenistan?
Provide a succinct answer. -1.55. In the year 2005, what is the difference between the ODA received (in %) of Malaysia and ODA received (in %) of Venezuela?
Your answer should be very brief. -0.07. In the year 2005, what is the difference between the ODA received (in %) in Tunisia and ODA received (in %) in Turkmenistan?
Keep it short and to the point. 3.54. In the year 2005, what is the difference between the ODA received (in %) of Tunisia and ODA received (in %) of Venezuela?
Your response must be concise. 5.03. In the year 2005, what is the difference between the ODA received (in %) of Turkmenistan and ODA received (in %) of Venezuela?
Give a very brief answer. 1.48. In the year 2006, what is the difference between the ODA received (in %) of Malaysia and ODA received (in %) of Tunisia?
Give a very brief answer. -4.7. In the year 2006, what is the difference between the ODA received (in %) in Malaysia and ODA received (in %) in Turkmenistan?
Provide a short and direct response. -1.39. In the year 2006, what is the difference between the ODA received (in %) of Malaysia and ODA received (in %) of Venezuela?
Give a very brief answer. 0.52. In the year 2006, what is the difference between the ODA received (in %) of Tunisia and ODA received (in %) of Turkmenistan?
Make the answer very short. 3.32. In the year 2006, what is the difference between the ODA received (in %) in Tunisia and ODA received (in %) in Venezuela?
Your answer should be compact. 5.22. In the year 2006, what is the difference between the ODA received (in %) of Turkmenistan and ODA received (in %) of Venezuela?
Offer a terse response. 1.9. In the year 2007, what is the difference between the ODA received (in %) in Malaysia and ODA received (in %) in Tunisia?
Offer a terse response. -3.02. In the year 2007, what is the difference between the ODA received (in %) in Malaysia and ODA received (in %) in Turkmenistan?
Provide a succinct answer. -0.77. In the year 2007, what is the difference between the ODA received (in %) in Malaysia and ODA received (in %) in Venezuela?
Offer a terse response. 0.33. In the year 2007, what is the difference between the ODA received (in %) in Tunisia and ODA received (in %) in Turkmenistan?
Offer a very short reply. 2.25. In the year 2007, what is the difference between the ODA received (in %) in Tunisia and ODA received (in %) in Venezuela?
Keep it short and to the point. 3.35. In the year 2007, what is the difference between the ODA received (in %) of Turkmenistan and ODA received (in %) of Venezuela?
Keep it short and to the point. 1.1. In the year 2008, what is the difference between the ODA received (in %) in Malaysia and ODA received (in %) in Tunisia?
Make the answer very short. -2.91. In the year 2008, what is the difference between the ODA received (in %) in Malaysia and ODA received (in %) in Turkmenistan?
Offer a very short reply. 0.02. In the year 2008, what is the difference between the ODA received (in %) in Malaysia and ODA received (in %) in Venezuela?
Your response must be concise. 0.24. In the year 2008, what is the difference between the ODA received (in %) of Tunisia and ODA received (in %) of Turkmenistan?
Offer a very short reply. 2.93. In the year 2008, what is the difference between the ODA received (in %) in Tunisia and ODA received (in %) in Venezuela?
Provide a short and direct response. 3.15. In the year 2008, what is the difference between the ODA received (in %) in Turkmenistan and ODA received (in %) in Venezuela?
Offer a very short reply. 0.23. In the year 2009, what is the difference between the ODA received (in %) of Malaysia and ODA received (in %) of Tunisia?
Provide a short and direct response. -4.23. In the year 2009, what is the difference between the ODA received (in %) of Malaysia and ODA received (in %) of Turkmenistan?
Your answer should be very brief. -0.03. In the year 2009, what is the difference between the ODA received (in %) of Malaysia and ODA received (in %) of Venezuela?
Keep it short and to the point. 0.32. In the year 2009, what is the difference between the ODA received (in %) in Tunisia and ODA received (in %) in Turkmenistan?
Ensure brevity in your answer.  4.21. In the year 2009, what is the difference between the ODA received (in %) of Tunisia and ODA received (in %) of Venezuela?
Provide a short and direct response. 4.55. In the year 2009, what is the difference between the ODA received (in %) of Turkmenistan and ODA received (in %) of Venezuela?
Provide a succinct answer. 0.34. In the year 2010, what is the difference between the ODA received (in %) in Malaysia and ODA received (in %) in Tunisia?
Your answer should be compact. -4.67. In the year 2010, what is the difference between the ODA received (in %) in Malaysia and ODA received (in %) in Turkmenistan?
Your response must be concise. -0.38. In the year 2010, what is the difference between the ODA received (in %) in Malaysia and ODA received (in %) in Venezuela?
Offer a very short reply. -0.06. In the year 2010, what is the difference between the ODA received (in %) of Tunisia and ODA received (in %) of Turkmenistan?
Your answer should be very brief. 4.3. In the year 2010, what is the difference between the ODA received (in %) in Tunisia and ODA received (in %) in Venezuela?
Keep it short and to the point. 4.62. In the year 2010, what is the difference between the ODA received (in %) of Turkmenistan and ODA received (in %) of Venezuela?
Ensure brevity in your answer.  0.32. In the year 2011, what is the difference between the ODA received (in %) of Malaysia and ODA received (in %) of Tunisia?
Your response must be concise. -8.45. In the year 2011, what is the difference between the ODA received (in %) of Malaysia and ODA received (in %) of Turkmenistan?
Offer a very short reply. -0.21. In the year 2011, what is the difference between the ODA received (in %) in Malaysia and ODA received (in %) in Venezuela?
Your response must be concise. -0.01. In the year 2011, what is the difference between the ODA received (in %) in Tunisia and ODA received (in %) in Turkmenistan?
Offer a terse response. 8.25. In the year 2011, what is the difference between the ODA received (in %) of Tunisia and ODA received (in %) of Venezuela?
Offer a very short reply. 8.44. In the year 2011, what is the difference between the ODA received (in %) of Turkmenistan and ODA received (in %) of Venezuela?
Ensure brevity in your answer.  0.19. In the year 2012, what is the difference between the ODA received (in %) of Malaysia and ODA received (in %) of Tunisia?
Your answer should be compact. -9.24. In the year 2012, what is the difference between the ODA received (in %) in Malaysia and ODA received (in %) in Turkmenistan?
Provide a short and direct response. -0.21. In the year 2012, what is the difference between the ODA received (in %) of Malaysia and ODA received (in %) of Venezuela?
Offer a very short reply. -0.03. In the year 2012, what is the difference between the ODA received (in %) of Tunisia and ODA received (in %) of Turkmenistan?
Keep it short and to the point. 9.03. In the year 2012, what is the difference between the ODA received (in %) of Tunisia and ODA received (in %) of Venezuela?
Keep it short and to the point. 9.21. In the year 2012, what is the difference between the ODA received (in %) in Turkmenistan and ODA received (in %) in Venezuela?
Provide a short and direct response. 0.18. What is the ratio of the ODA received (in %) of Malaysia in 2005 to that in 2006?
Provide a short and direct response. 0.13. What is the ratio of the ODA received (in %) in Turkmenistan in 2005 to that in 2006?
Your answer should be compact. 0.81. What is the ratio of the ODA received (in %) in Venezuela in 2005 to that in 2006?
Provide a short and direct response. 1.18. What is the ratio of the ODA received (in %) of Malaysia in 2005 to that in 2007?
Provide a succinct answer. 0.18. What is the ratio of the ODA received (in %) in Tunisia in 2005 to that in 2007?
Give a very brief answer. 1.5. What is the ratio of the ODA received (in %) in Turkmenistan in 2005 to that in 2007?
Your answer should be compact. 1.35. What is the ratio of the ODA received (in %) in Venezuela in 2005 to that in 2007?
Your answer should be very brief. 1.35. What is the ratio of the ODA received (in %) in Malaysia in 2005 to that in 2008?
Ensure brevity in your answer.  0.26. What is the ratio of the ODA received (in %) in Tunisia in 2005 to that in 2008?
Provide a succinct answer. 1.61. What is the ratio of the ODA received (in %) of Turkmenistan in 2005 to that in 2008?
Provide a short and direct response. 5.51. What is the ratio of the ODA received (in %) in Venezuela in 2005 to that in 2008?
Your answer should be very brief. 2.15. What is the ratio of the ODA received (in %) in Malaysia in 2005 to that in 2009?
Provide a short and direct response. 0.21. What is the ratio of the ODA received (in %) in Tunisia in 2005 to that in 2009?
Offer a very short reply. 1.12. What is the ratio of the ODA received (in %) of Turkmenistan in 2005 to that in 2009?
Give a very brief answer. 3.87. What is the ratio of the ODA received (in %) in Venezuela in 2005 to that in 2009?
Provide a succinct answer. 1.92. What is the ratio of the ODA received (in %) in Malaysia in 2005 to that in 2010?
Your answer should be very brief. 23.55. What is the ratio of the ODA received (in %) in Tunisia in 2005 to that in 2010?
Provide a short and direct response. 1.11. What is the ratio of the ODA received (in %) in Turkmenistan in 2005 to that in 2010?
Offer a very short reply. 4.29. What is the ratio of the ODA received (in %) in Venezuela in 2005 to that in 2010?
Your answer should be very brief. 2.47. What is the ratio of the ODA received (in %) of Malaysia in 2005 to that in 2011?
Provide a short and direct response. 1.75. What is the ratio of the ODA received (in %) in Tunisia in 2005 to that in 2011?
Provide a short and direct response. 0.61. What is the ratio of the ODA received (in %) in Turkmenistan in 2005 to that in 2011?
Make the answer very short. 6.42. What is the ratio of the ODA received (in %) in Venezuela in 2005 to that in 2011?
Offer a very short reply. 2.45. What is the ratio of the ODA received (in %) of Malaysia in 2005 to that in 2012?
Keep it short and to the point. 4.29. What is the ratio of the ODA received (in %) of Tunisia in 2005 to that in 2012?
Offer a very short reply. 0.56. What is the ratio of the ODA received (in %) in Turkmenistan in 2005 to that in 2012?
Make the answer very short. 7.14. What is the ratio of the ODA received (in %) in Venezuela in 2005 to that in 2012?
Your answer should be compact. 3.17. What is the ratio of the ODA received (in %) in Malaysia in 2006 to that in 2007?
Keep it short and to the point. 1.46. What is the ratio of the ODA received (in %) of Tunisia in 2006 to that in 2007?
Offer a very short reply. 1.55. What is the ratio of the ODA received (in %) in Turkmenistan in 2006 to that in 2007?
Keep it short and to the point. 1.68. What is the ratio of the ODA received (in %) in Venezuela in 2006 to that in 2007?
Offer a terse response. 1.15. What is the ratio of the ODA received (in %) in Malaysia in 2006 to that in 2008?
Offer a terse response. 2.07. What is the ratio of the ODA received (in %) in Tunisia in 2006 to that in 2008?
Offer a terse response. 1.66. What is the ratio of the ODA received (in %) in Turkmenistan in 2006 to that in 2008?
Your answer should be very brief. 6.84. What is the ratio of the ODA received (in %) in Venezuela in 2006 to that in 2008?
Make the answer very short. 1.82. What is the ratio of the ODA received (in %) of Malaysia in 2006 to that in 2009?
Your answer should be compact. 1.63. What is the ratio of the ODA received (in %) of Tunisia in 2006 to that in 2009?
Provide a short and direct response. 1.16. What is the ratio of the ODA received (in %) in Turkmenistan in 2006 to that in 2009?
Keep it short and to the point. 4.8. What is the ratio of the ODA received (in %) in Venezuela in 2006 to that in 2009?
Provide a short and direct response. 1.63. What is the ratio of the ODA received (in %) of Malaysia in 2006 to that in 2010?
Your response must be concise. 187.1. What is the ratio of the ODA received (in %) in Tunisia in 2006 to that in 2010?
Make the answer very short. 1.14. What is the ratio of the ODA received (in %) of Turkmenistan in 2006 to that in 2010?
Provide a short and direct response. 5.33. What is the ratio of the ODA received (in %) in Venezuela in 2006 to that in 2010?
Ensure brevity in your answer.  2.09. What is the ratio of the ODA received (in %) in Malaysia in 2006 to that in 2011?
Make the answer very short. 13.91. What is the ratio of the ODA received (in %) of Tunisia in 2006 to that in 2011?
Ensure brevity in your answer.  0.63. What is the ratio of the ODA received (in %) in Turkmenistan in 2006 to that in 2011?
Provide a short and direct response. 7.97. What is the ratio of the ODA received (in %) in Venezuela in 2006 to that in 2011?
Offer a very short reply. 2.07. What is the ratio of the ODA received (in %) in Malaysia in 2006 to that in 2012?
Your answer should be compact. 34.04. What is the ratio of the ODA received (in %) in Tunisia in 2006 to that in 2012?
Your response must be concise. 0.58. What is the ratio of the ODA received (in %) in Turkmenistan in 2006 to that in 2012?
Offer a very short reply. 8.87. What is the ratio of the ODA received (in %) in Venezuela in 2006 to that in 2012?
Your answer should be very brief. 2.68. What is the ratio of the ODA received (in %) of Malaysia in 2007 to that in 2008?
Your response must be concise. 1.42. What is the ratio of the ODA received (in %) in Tunisia in 2007 to that in 2008?
Provide a succinct answer. 1.07. What is the ratio of the ODA received (in %) of Turkmenistan in 2007 to that in 2008?
Your response must be concise. 4.07. What is the ratio of the ODA received (in %) in Venezuela in 2007 to that in 2008?
Give a very brief answer. 1.59. What is the ratio of the ODA received (in %) in Malaysia in 2007 to that in 2009?
Keep it short and to the point. 1.11. What is the ratio of the ODA received (in %) of Tunisia in 2007 to that in 2009?
Your answer should be compact. 0.75. What is the ratio of the ODA received (in %) of Turkmenistan in 2007 to that in 2009?
Ensure brevity in your answer.  2.86. What is the ratio of the ODA received (in %) of Venezuela in 2007 to that in 2009?
Provide a short and direct response. 1.43. What is the ratio of the ODA received (in %) of Malaysia in 2007 to that in 2010?
Give a very brief answer. 127.88. What is the ratio of the ODA received (in %) in Tunisia in 2007 to that in 2010?
Your answer should be very brief. 0.74. What is the ratio of the ODA received (in %) of Turkmenistan in 2007 to that in 2010?
Offer a terse response. 3.17. What is the ratio of the ODA received (in %) in Venezuela in 2007 to that in 2010?
Keep it short and to the point. 1.83. What is the ratio of the ODA received (in %) in Malaysia in 2007 to that in 2011?
Ensure brevity in your answer.  9.51. What is the ratio of the ODA received (in %) of Tunisia in 2007 to that in 2011?
Give a very brief answer. 0.41. What is the ratio of the ODA received (in %) in Turkmenistan in 2007 to that in 2011?
Your answer should be very brief. 4.75. What is the ratio of the ODA received (in %) in Venezuela in 2007 to that in 2011?
Give a very brief answer. 1.81. What is the ratio of the ODA received (in %) of Malaysia in 2007 to that in 2012?
Give a very brief answer. 23.27. What is the ratio of the ODA received (in %) of Tunisia in 2007 to that in 2012?
Ensure brevity in your answer.  0.37. What is the ratio of the ODA received (in %) of Turkmenistan in 2007 to that in 2012?
Keep it short and to the point. 5.28. What is the ratio of the ODA received (in %) of Venezuela in 2007 to that in 2012?
Give a very brief answer. 2.34. What is the ratio of the ODA received (in %) in Malaysia in 2008 to that in 2009?
Offer a terse response. 0.79. What is the ratio of the ODA received (in %) of Tunisia in 2008 to that in 2009?
Your answer should be very brief. 0.7. What is the ratio of the ODA received (in %) of Turkmenistan in 2008 to that in 2009?
Ensure brevity in your answer.  0.7. What is the ratio of the ODA received (in %) in Venezuela in 2008 to that in 2009?
Ensure brevity in your answer.  0.9. What is the ratio of the ODA received (in %) of Malaysia in 2008 to that in 2010?
Keep it short and to the point. 90.32. What is the ratio of the ODA received (in %) in Tunisia in 2008 to that in 2010?
Offer a very short reply. 0.69. What is the ratio of the ODA received (in %) of Turkmenistan in 2008 to that in 2010?
Your answer should be very brief. 0.78. What is the ratio of the ODA received (in %) of Venezuela in 2008 to that in 2010?
Ensure brevity in your answer.  1.15. What is the ratio of the ODA received (in %) in Malaysia in 2008 to that in 2011?
Offer a very short reply. 6.71. What is the ratio of the ODA received (in %) of Tunisia in 2008 to that in 2011?
Give a very brief answer. 0.38. What is the ratio of the ODA received (in %) in Turkmenistan in 2008 to that in 2011?
Give a very brief answer. 1.16. What is the ratio of the ODA received (in %) in Venezuela in 2008 to that in 2011?
Your answer should be very brief. 1.14. What is the ratio of the ODA received (in %) of Malaysia in 2008 to that in 2012?
Provide a short and direct response. 16.43. What is the ratio of the ODA received (in %) of Tunisia in 2008 to that in 2012?
Your response must be concise. 0.35. What is the ratio of the ODA received (in %) of Turkmenistan in 2008 to that in 2012?
Give a very brief answer. 1.3. What is the ratio of the ODA received (in %) in Venezuela in 2008 to that in 2012?
Your response must be concise. 1.47. What is the ratio of the ODA received (in %) of Malaysia in 2009 to that in 2010?
Give a very brief answer. 114.73. What is the ratio of the ODA received (in %) of Tunisia in 2009 to that in 2010?
Give a very brief answer. 0.99. What is the ratio of the ODA received (in %) of Turkmenistan in 2009 to that in 2010?
Provide a short and direct response. 1.11. What is the ratio of the ODA received (in %) in Venezuela in 2009 to that in 2010?
Offer a terse response. 1.28. What is the ratio of the ODA received (in %) of Malaysia in 2009 to that in 2011?
Offer a very short reply. 8.53. What is the ratio of the ODA received (in %) in Tunisia in 2009 to that in 2011?
Your response must be concise. 0.54. What is the ratio of the ODA received (in %) in Turkmenistan in 2009 to that in 2011?
Your response must be concise. 1.66. What is the ratio of the ODA received (in %) of Venezuela in 2009 to that in 2011?
Give a very brief answer. 1.27. What is the ratio of the ODA received (in %) in Malaysia in 2009 to that in 2012?
Make the answer very short. 20.88. What is the ratio of the ODA received (in %) in Tunisia in 2009 to that in 2012?
Provide a succinct answer. 0.5. What is the ratio of the ODA received (in %) in Turkmenistan in 2009 to that in 2012?
Ensure brevity in your answer.  1.85. What is the ratio of the ODA received (in %) of Venezuela in 2009 to that in 2012?
Provide a short and direct response. 1.64. What is the ratio of the ODA received (in %) in Malaysia in 2010 to that in 2011?
Offer a terse response. 0.07. What is the ratio of the ODA received (in %) of Tunisia in 2010 to that in 2011?
Offer a very short reply. 0.55. What is the ratio of the ODA received (in %) in Turkmenistan in 2010 to that in 2011?
Your response must be concise. 1.5. What is the ratio of the ODA received (in %) of Malaysia in 2010 to that in 2012?
Your answer should be compact. 0.18. What is the ratio of the ODA received (in %) in Tunisia in 2010 to that in 2012?
Keep it short and to the point. 0.51. What is the ratio of the ODA received (in %) of Turkmenistan in 2010 to that in 2012?
Make the answer very short. 1.66. What is the ratio of the ODA received (in %) in Venezuela in 2010 to that in 2012?
Provide a succinct answer. 1.28. What is the ratio of the ODA received (in %) in Malaysia in 2011 to that in 2012?
Provide a succinct answer. 2.45. What is the ratio of the ODA received (in %) of Tunisia in 2011 to that in 2012?
Make the answer very short. 0.92. What is the ratio of the ODA received (in %) of Turkmenistan in 2011 to that in 2012?
Your answer should be very brief. 1.11. What is the ratio of the ODA received (in %) in Venezuela in 2011 to that in 2012?
Ensure brevity in your answer.  1.29. What is the difference between the highest and the second highest ODA received (in %) in Malaysia?
Your answer should be very brief. 0.2. What is the difference between the highest and the second highest ODA received (in %) of Tunisia?
Provide a short and direct response. 0.76. What is the difference between the highest and the second highest ODA received (in %) of Turkmenistan?
Provide a succinct answer. 0.4. What is the difference between the highest and the second highest ODA received (in %) in Venezuela?
Your answer should be very brief. 0.02. What is the difference between the highest and the lowest ODA received (in %) of Malaysia?
Make the answer very short. 0.64. What is the difference between the highest and the lowest ODA received (in %) in Tunisia?
Your answer should be compact. 6.03. What is the difference between the highest and the lowest ODA received (in %) of Turkmenistan?
Give a very brief answer. 1.8. What is the difference between the highest and the lowest ODA received (in %) of Venezuela?
Provide a succinct answer. 0.1. 